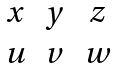<formula> <loc_0><loc_0><loc_500><loc_500>\begin{matrix} x & y & z \\ u & v & w \end{matrix}</formula> 